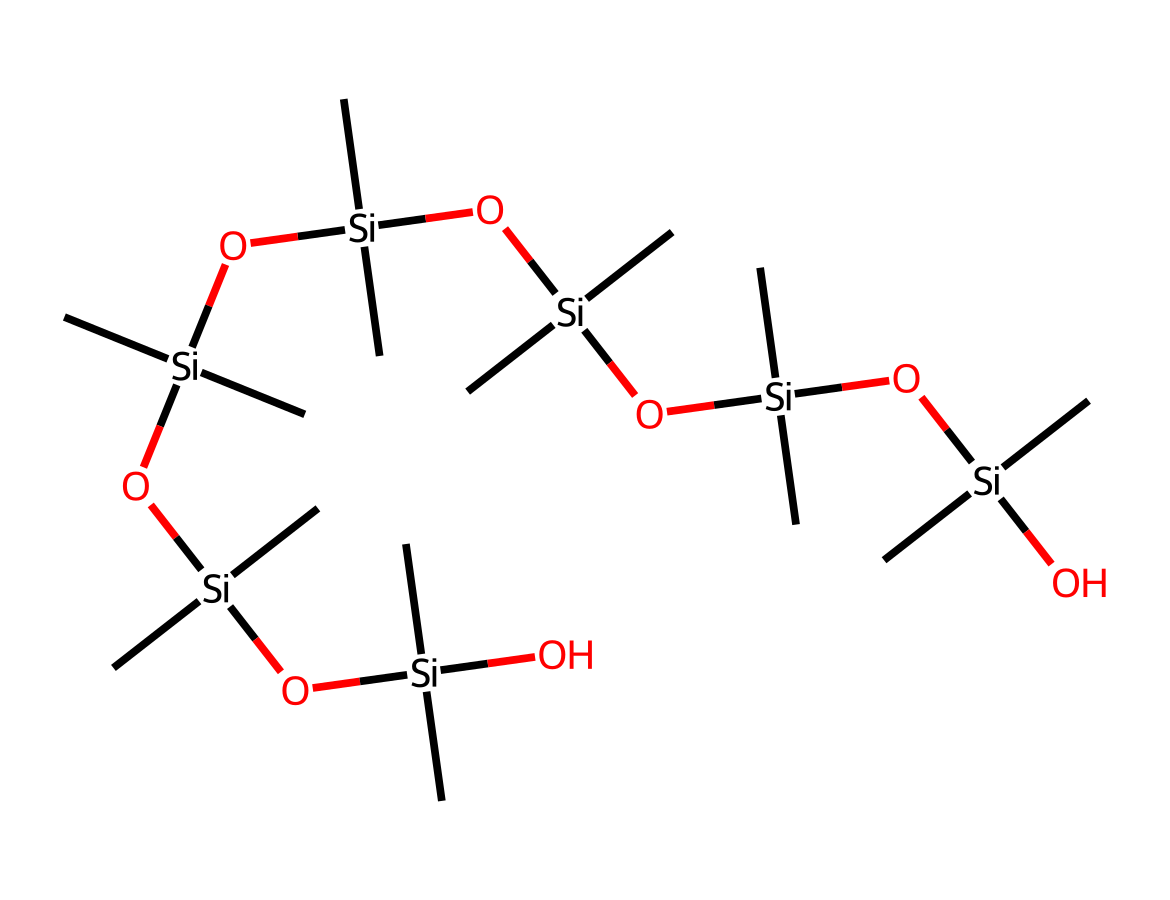What is the main functional group present in dimethicone? The main functional group in dimethicone is the siloxane group, indicated by the presence of silicon atoms bonded with oxygen (Si-O) in the structure.
Answer: siloxane How many silicon atoms are present in the dimethicone structure? By analyzing the SMILES representation, we can count that there are four silicon atoms (Si) present.
Answer: four What type of chemical bonds primarily connect the silicon atoms in dimethicone? The bonds connecting the silicon atoms in dimethicone are primarily siloxane bonds (Si-O), which are characteristic of organosilicon compounds.
Answer: siloxane How many carbon atoms accompany each silicon atom in the dimethicone structure? In the structure, each silicon atom is bonded to two carbon atoms, which are represented by "C" in the SMILES. Each Si has 2 CH3 groups.
Answer: two What is the overall molecular behavior of dimethicone when used in culinary applications? Dimethicone acts as a non-sticky, smooth emulsifier and stabilizer that can enhance texture and moisture retention in food products.
Answer: emulsifier What is the molecular formula derived from the SMILES representation? From the given SMILES, the molecular formula can be calculated as C12H38O5Si5, considering the contributions of carbon, hydrogen, oxygen, and silicon.
Answer: C12H38O5Si5 